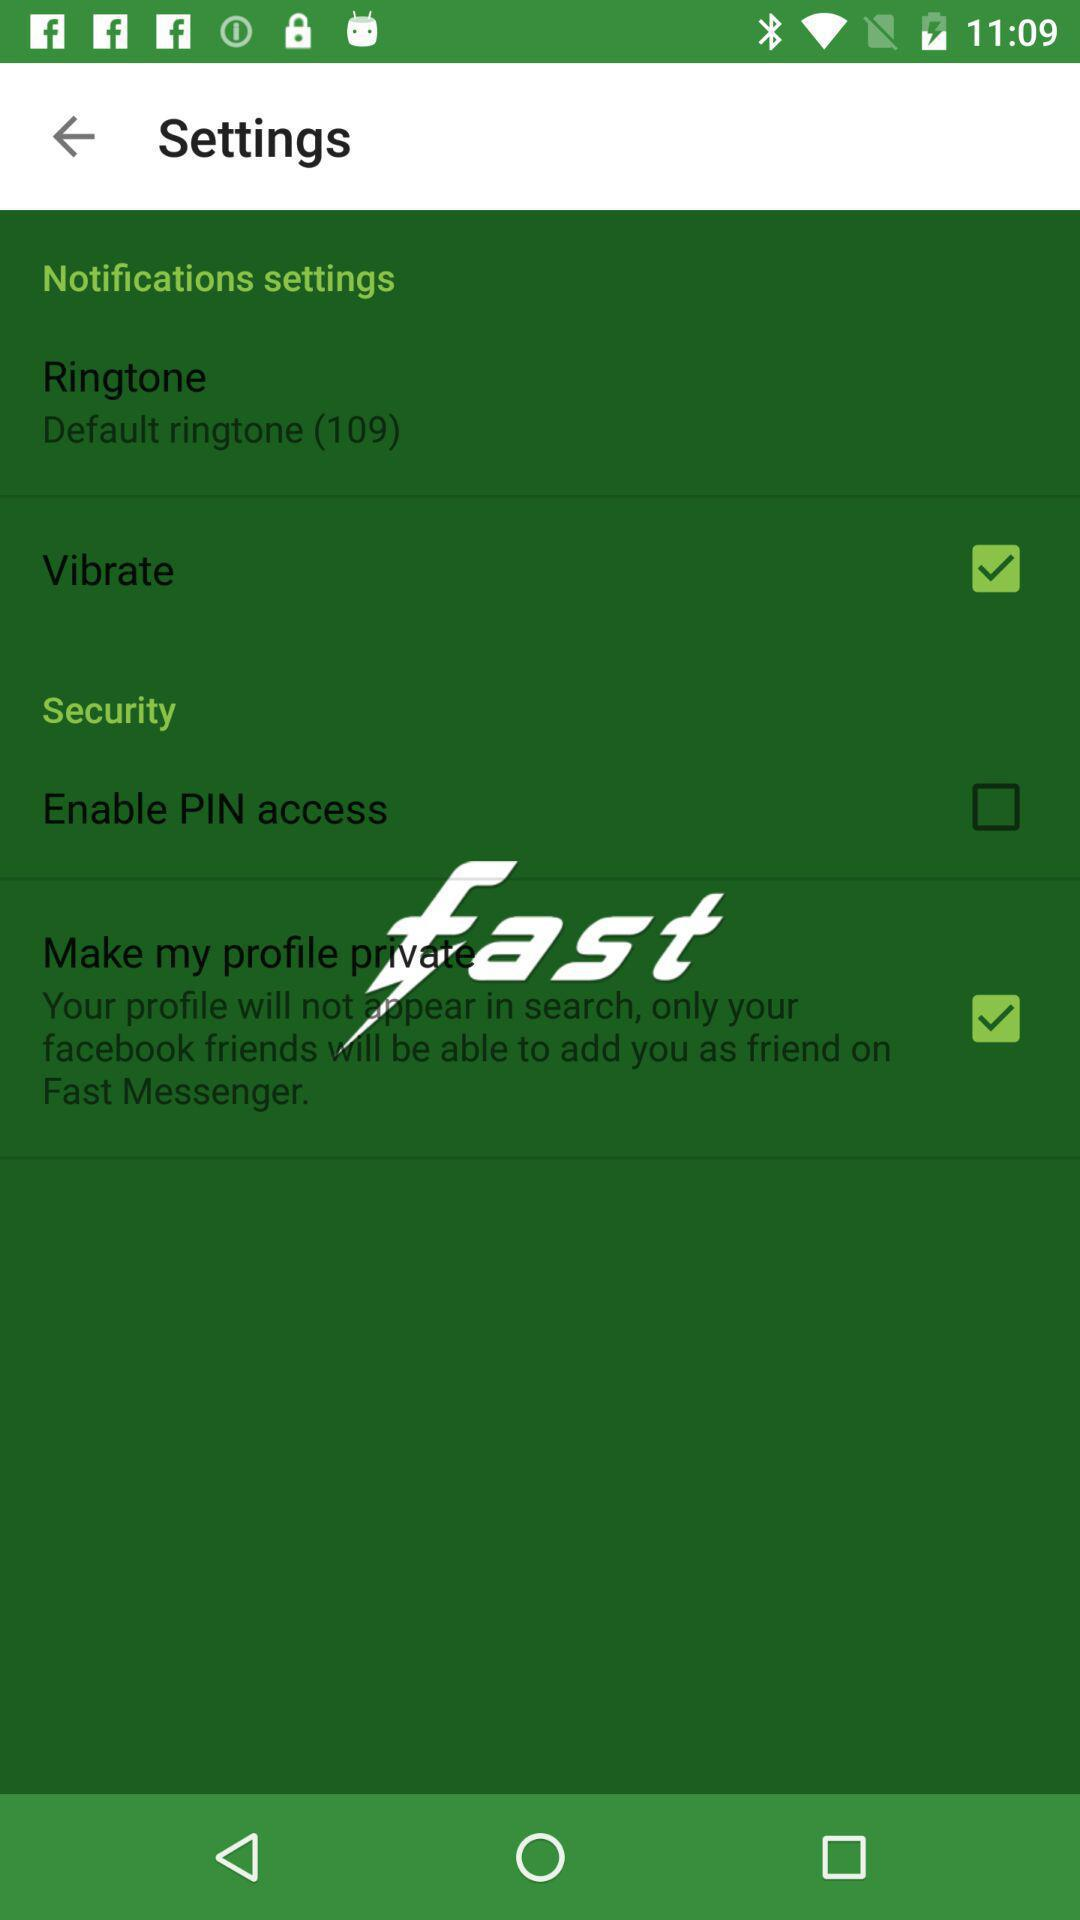What is the status of the vibrate setting? The status is "on". 